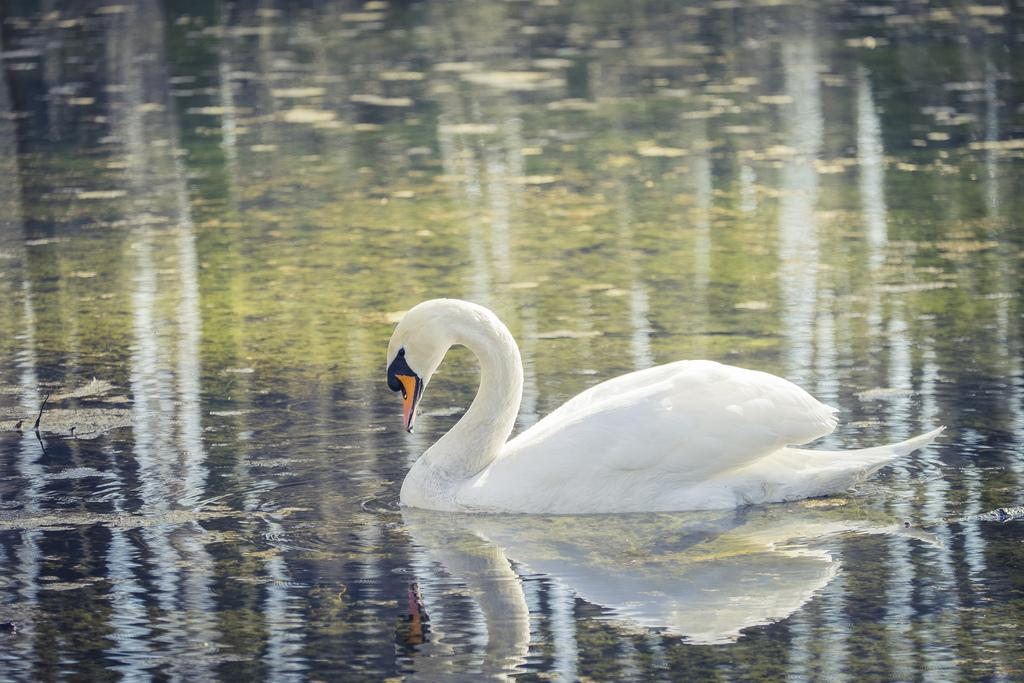What is the main subject of the picture? The main subject of the picture is a swan. What is the swan doing in the picture? The swan is in the water. What color is the swan? The swan is white in color. What is the color of the swan's beak? The swan has a yellow beak. Can you tell me how many threads are attached to the swan's wing in the image? There are no threads attached to the swan's wing in the image; it is a swan swimming in the water. Is there an actor playing the role of a swan in the image? There is no actor or any representation of a human in the image; it is a photograph of a real swan. 